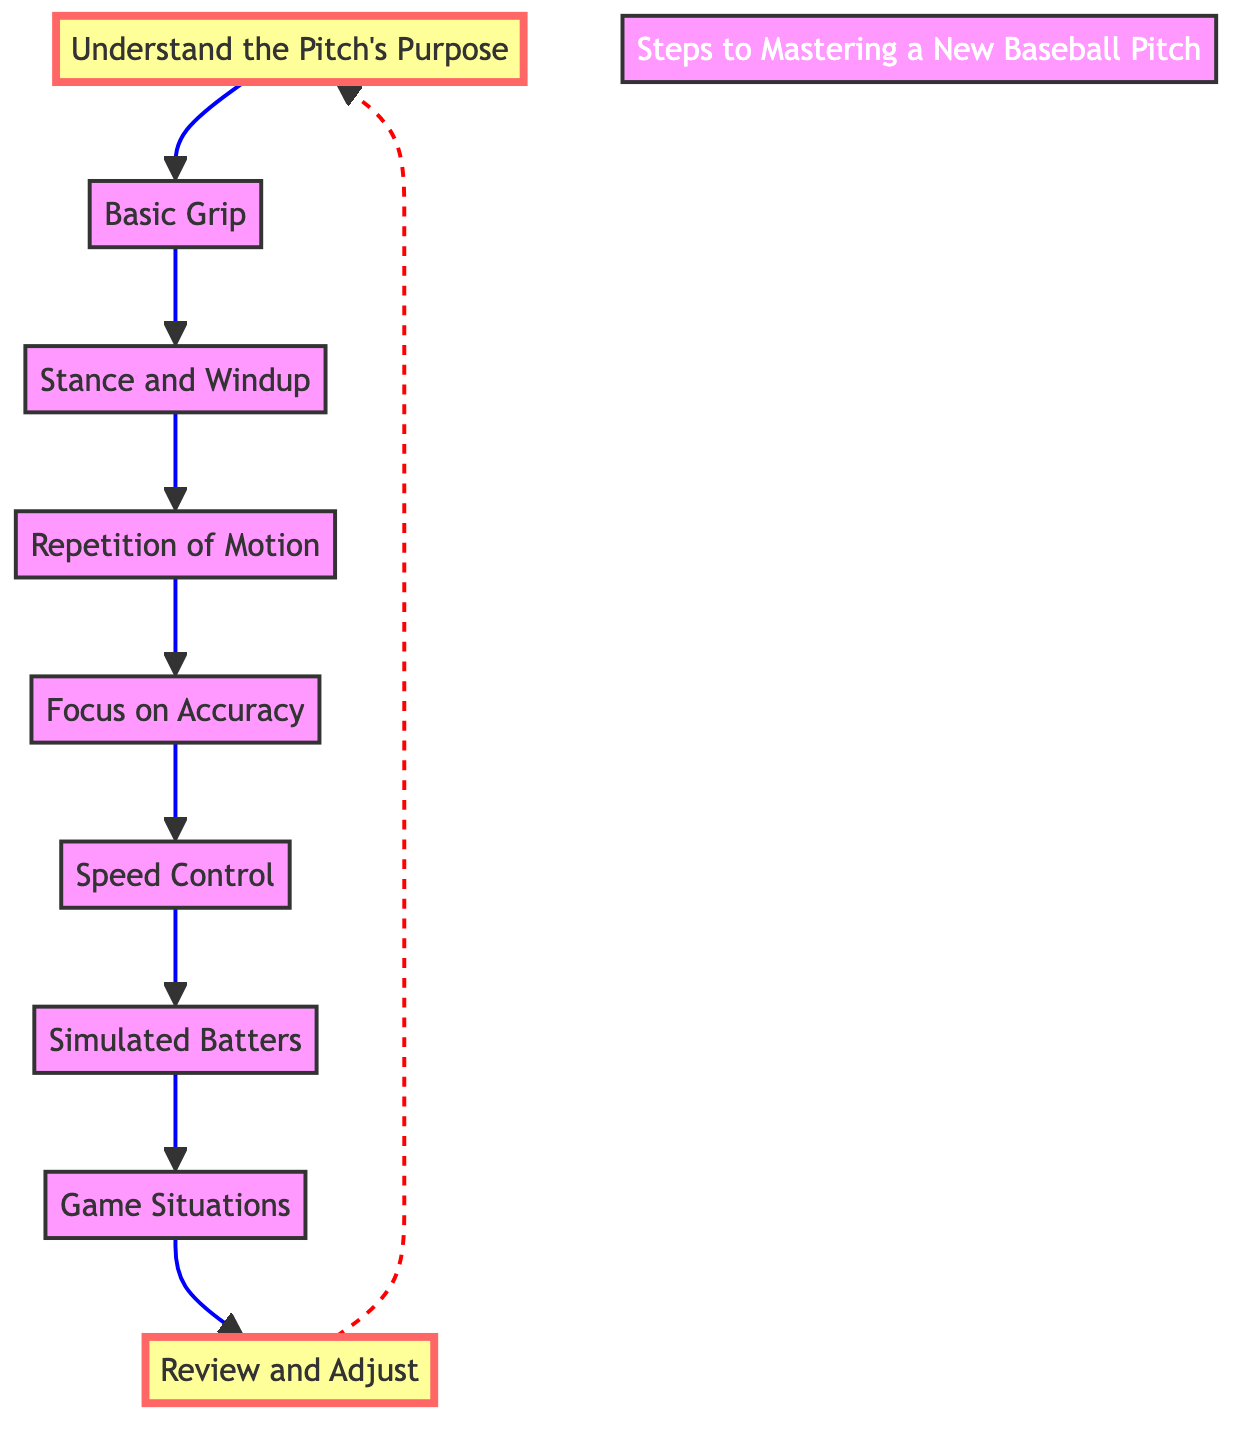What is the first step in mastering a new baseball pitch? The diagram clearly shows that the first step is labeled "Understand the Pitch's Purpose," which indicates the starting point of the process.
Answer: Understand the Pitch's Purpose How many total steps are shown in the diagram? By counting the number of distinct steps listed in the diagram, I find there are nine steps in total.
Answer: 9 What comes after "Basic Grip" in the flow? Following the "Basic Grip," the next step is "Stance and Windup," which is directly connected in the diagram.
Answer: Stance and Windup What is the last step mentioned in the process? The final step of the flow is labeled "Review and Adjust," indicating that after practicing and implementing the pitch, it is essential to evaluate performance.
Answer: Review and Adjust Which two steps are highlighted in the diagram? The diagram highlights "Understand the Pitch's Purpose" and "Review and Adjust," indicating their importance in the process.
Answer: Understand the Pitch's Purpose, Review and Adjust What type of motion is practiced in step four? Step four describes the practice of the "Repetition of Motion," which focuses on repeating the pitching action to develop muscle memory.
Answer: Repetition of Motion What step involves pitching to a catcher? Step seven discusses "Simulated Batters," where the player practices pitching to a catcher to simulate game conditions.
Answer: Simulated Batters How many steps are involved before focusing on accuracy? There are four steps before reaching the focus on accuracy, which is step five, these are steps one through four.
Answer: 4 What is the purpose of step six, "Speed Control"? Step six is focused on learning how to manage the pitch's speed while still keeping control, which is essential for effective pitching.
Answer: Adjust speed of the pitch 